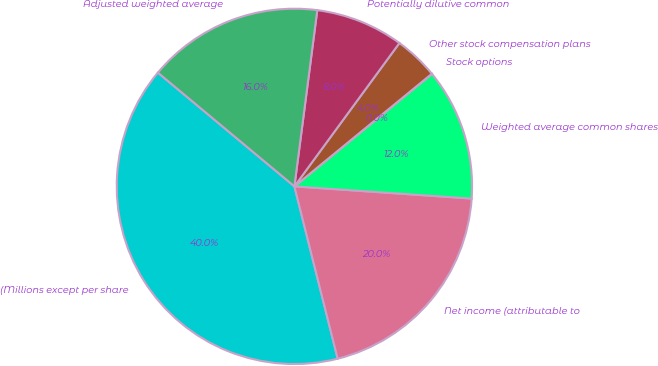Convert chart. <chart><loc_0><loc_0><loc_500><loc_500><pie_chart><fcel>(Millions except per share<fcel>Net income (attributable to<fcel>Weighted average common shares<fcel>Stock options<fcel>Other stock compensation plans<fcel>Potentially dilutive common<fcel>Adjusted weighted average<nl><fcel>39.97%<fcel>19.99%<fcel>12.0%<fcel>0.02%<fcel>4.01%<fcel>8.01%<fcel>16.0%<nl></chart> 